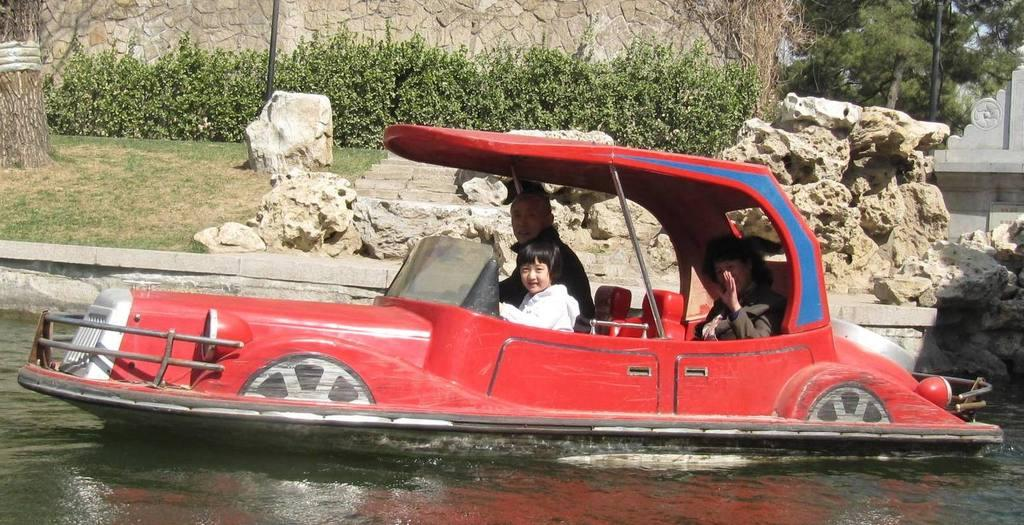What are the people in the image doing? There are three people sitting on a boat in the center of the image. What can be seen at the bottom of the image? There is a wall, plants, trees, rocks, stairs, and poles present at the bottom of the image. How many children are holding oranges in the image? There are no children or oranges present in the image. What is the person doing with their finger in the image? There is no person using their finger in the image. 